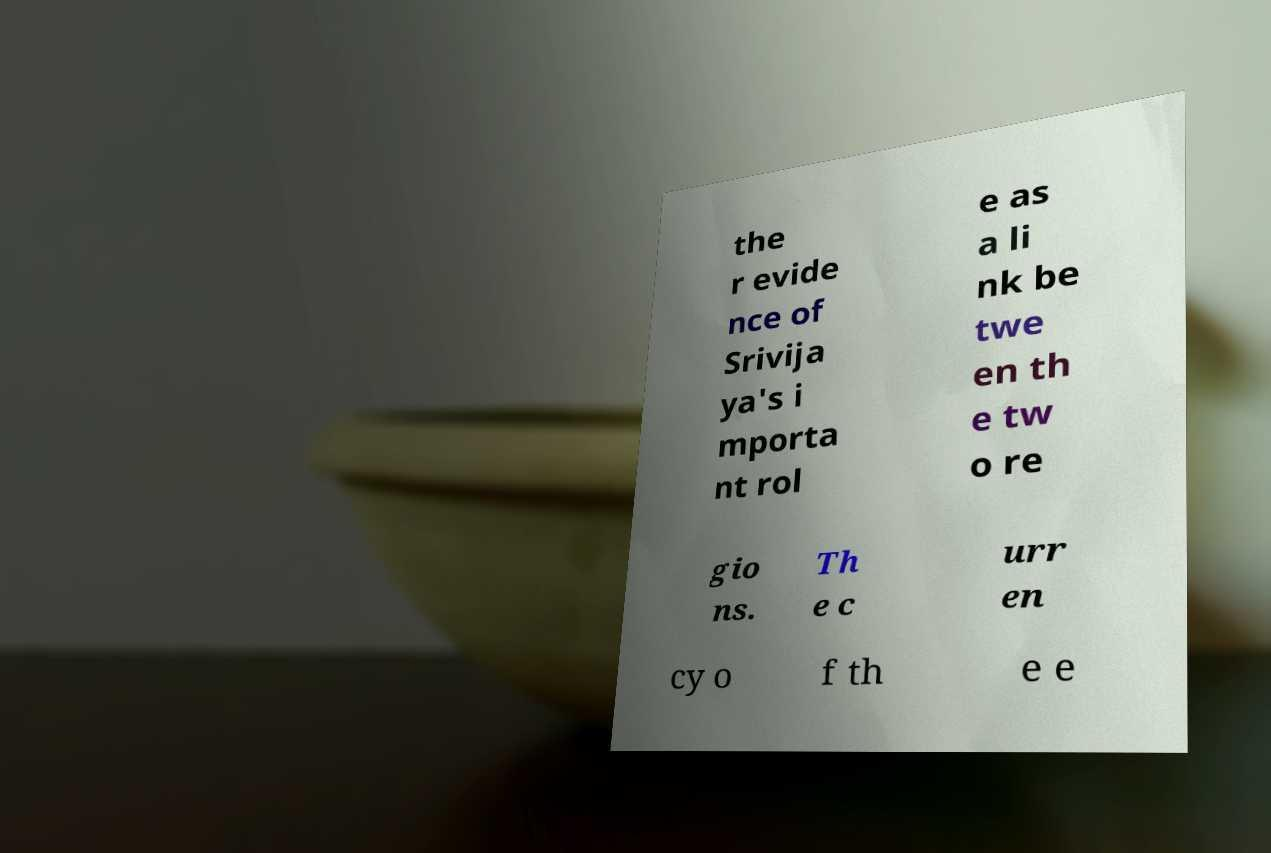Please identify and transcribe the text found in this image. the r evide nce of Srivija ya's i mporta nt rol e as a li nk be twe en th e tw o re gio ns. Th e c urr en cy o f th e e 